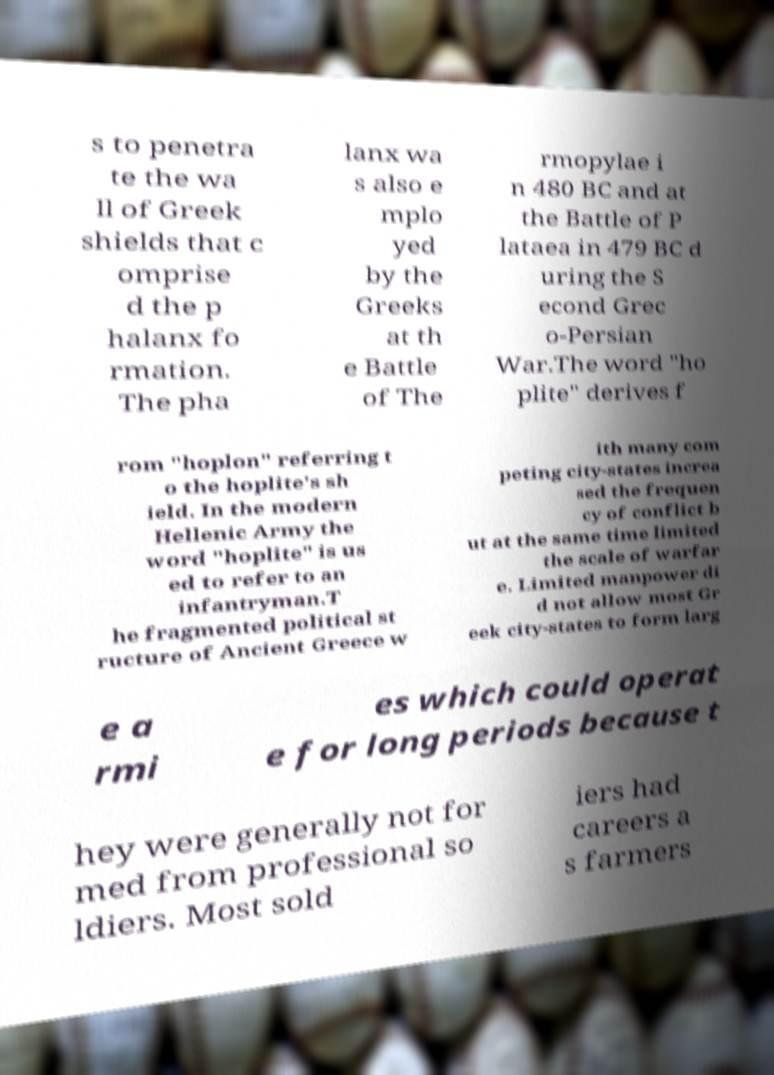Please identify and transcribe the text found in this image. s to penetra te the wa ll of Greek shields that c omprise d the p halanx fo rmation. The pha lanx wa s also e mplo yed by the Greeks at th e Battle of The rmopylae i n 480 BC and at the Battle of P lataea in 479 BC d uring the S econd Grec o-Persian War.The word "ho plite" derives f rom "hoplon" referring t o the hoplite's sh ield. In the modern Hellenic Army the word "hoplite" is us ed to refer to an infantryman.T he fragmented political st ructure of Ancient Greece w ith many com peting city-states increa sed the frequen cy of conflict b ut at the same time limited the scale of warfar e. Limited manpower di d not allow most Gr eek city-states to form larg e a rmi es which could operat e for long periods because t hey were generally not for med from professional so ldiers. Most sold iers had careers a s farmers 